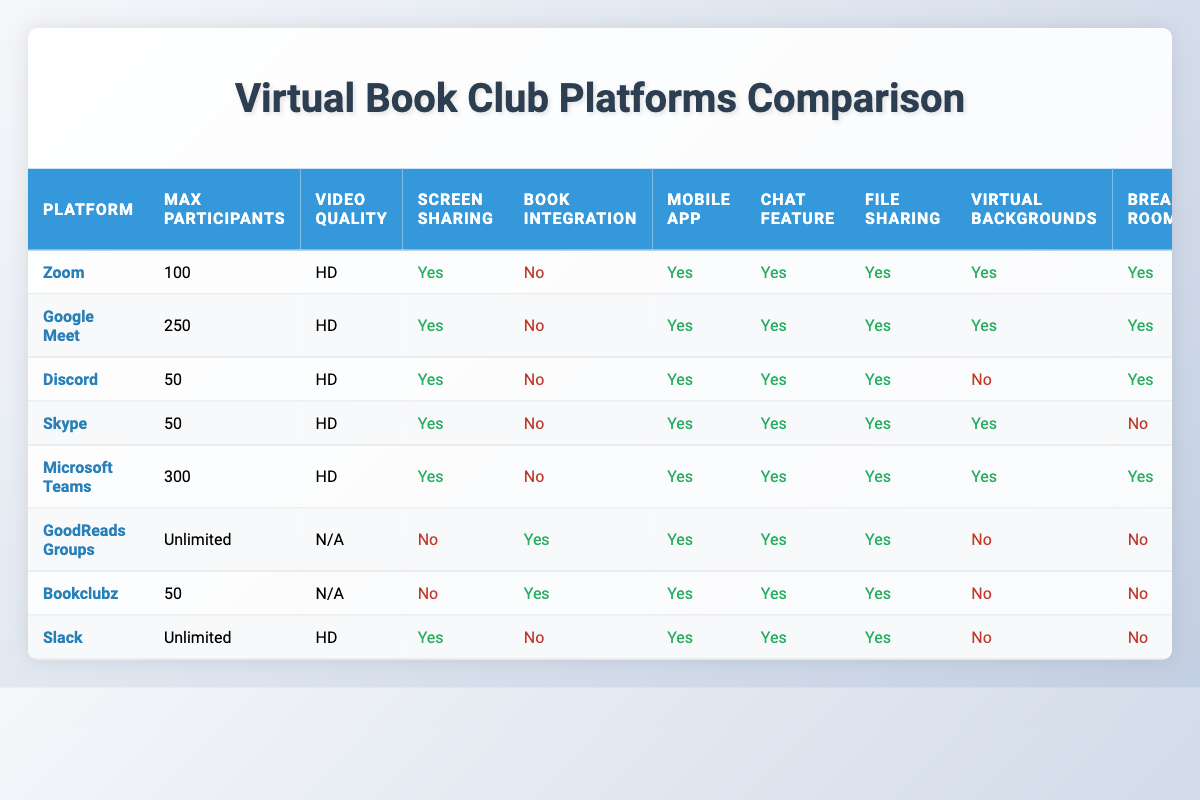What is the maximum number of participants allowed on Google Meet? The table shows that Google Meet can support up to 250 participants as per the "Max Participants" column under the "Google Meet" row.
Answer: 250 Which platform offers book integration features? According to the "Book Integration" column, GoodReads Groups and Bookclubz are the only platforms that offer book integration features, as indicated by "Yes" in their respective rows.
Answer: GoodReads Groups and Bookclubz How many platforms have breakout rooms available? By checking the "Breakout Rooms" column, platforms with "Yes" are Zoom, Google Meet, and Microsoft Teams. Thus, there are three platforms that offer this feature.
Answer: 3 Is chat feature available on all listed platforms? The "Chat Feature" column indicates "Yes" for every platform listed, confirming that all platforms provide this feature.
Answer: Yes Which platform has the highest number of monthly active users? By reviewing the "Monthly Active Users" column, Zoom has the highest count with 300,000,000 users.
Answer: Zoom What is the difference in the number of language supports between Google Meet and Skype? Google Meet has 74 languages supported while Skype has 108. The difference is calculated as 108 - 74 = 34 languages.
Answer: 34 Does Discord allow screen sharing? The table shows that screen sharing is marked as "Yes" in the "Screen Sharing" column for Discord.
Answer: Yes Which platforms do not have virtual backgrounds? The "Virtual Backgrounds" column indicates that Discord, GoodReads Groups, Bookclubz, and Slack do not support virtual backgrounds as they are marked "No".
Answer: Discord, GoodReads Groups, Bookclubz, Slack How many platforms offer a free version? The "Free Version Available" column indicates that all the listed platforms offer a free version since all entries are marked "Yes".
Answer: All platforms What percentage of platforms have end-to-end encryption? There are 8 platforms total, and 6 of them provide end-to-end encryption (Zoom, Google Meet, Discord, Skype, Microsoft Teams, and Slack). Thus, the percentage is (6/8) * 100 = 75%.
Answer: 75% 